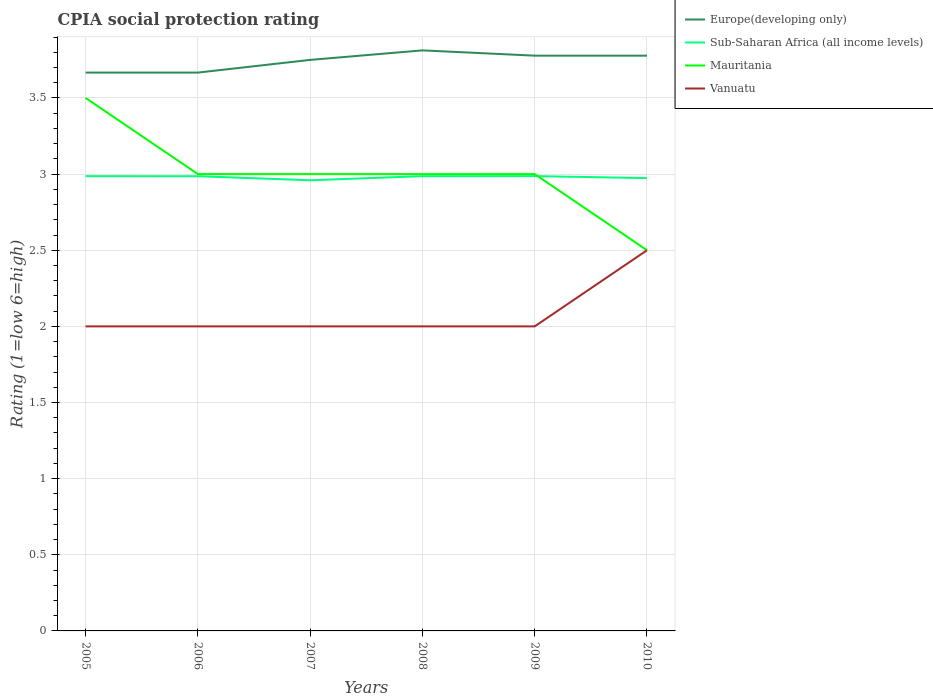Does the line corresponding to Sub-Saharan Africa (all income levels) intersect with the line corresponding to Mauritania?
Your response must be concise. Yes. Across all years, what is the maximum CPIA rating in Sub-Saharan Africa (all income levels)?
Offer a terse response. 2.96. What is the difference between the highest and the second highest CPIA rating in Mauritania?
Your answer should be very brief. 1. What is the difference between the highest and the lowest CPIA rating in Vanuatu?
Your response must be concise. 1. Is the CPIA rating in Vanuatu strictly greater than the CPIA rating in Sub-Saharan Africa (all income levels) over the years?
Offer a very short reply. Yes. What is the difference between two consecutive major ticks on the Y-axis?
Provide a short and direct response. 0.5. Does the graph contain any zero values?
Keep it short and to the point. No. Does the graph contain grids?
Provide a short and direct response. Yes. What is the title of the graph?
Provide a succinct answer. CPIA social protection rating. Does "Jamaica" appear as one of the legend labels in the graph?
Provide a succinct answer. No. What is the label or title of the X-axis?
Offer a terse response. Years. What is the label or title of the Y-axis?
Offer a very short reply. Rating (1=low 6=high). What is the Rating (1=low 6=high) of Europe(developing only) in 2005?
Your response must be concise. 3.67. What is the Rating (1=low 6=high) in Sub-Saharan Africa (all income levels) in 2005?
Your response must be concise. 2.99. What is the Rating (1=low 6=high) in Europe(developing only) in 2006?
Offer a very short reply. 3.67. What is the Rating (1=low 6=high) of Sub-Saharan Africa (all income levels) in 2006?
Provide a succinct answer. 2.99. What is the Rating (1=low 6=high) in Mauritania in 2006?
Your answer should be very brief. 3. What is the Rating (1=low 6=high) of Europe(developing only) in 2007?
Offer a terse response. 3.75. What is the Rating (1=low 6=high) in Sub-Saharan Africa (all income levels) in 2007?
Offer a terse response. 2.96. What is the Rating (1=low 6=high) of Vanuatu in 2007?
Provide a succinct answer. 2. What is the Rating (1=low 6=high) of Europe(developing only) in 2008?
Your answer should be compact. 3.81. What is the Rating (1=low 6=high) of Sub-Saharan Africa (all income levels) in 2008?
Offer a terse response. 2.99. What is the Rating (1=low 6=high) in Vanuatu in 2008?
Your response must be concise. 2. What is the Rating (1=low 6=high) in Europe(developing only) in 2009?
Provide a short and direct response. 3.78. What is the Rating (1=low 6=high) of Sub-Saharan Africa (all income levels) in 2009?
Your answer should be very brief. 2.99. What is the Rating (1=low 6=high) of Mauritania in 2009?
Make the answer very short. 3. What is the Rating (1=low 6=high) in Vanuatu in 2009?
Your response must be concise. 2. What is the Rating (1=low 6=high) in Europe(developing only) in 2010?
Offer a terse response. 3.78. What is the Rating (1=low 6=high) in Sub-Saharan Africa (all income levels) in 2010?
Offer a very short reply. 2.97. What is the Rating (1=low 6=high) of Mauritania in 2010?
Ensure brevity in your answer.  2.5. Across all years, what is the maximum Rating (1=low 6=high) of Europe(developing only)?
Give a very brief answer. 3.81. Across all years, what is the maximum Rating (1=low 6=high) of Sub-Saharan Africa (all income levels)?
Your response must be concise. 2.99. Across all years, what is the maximum Rating (1=low 6=high) in Vanuatu?
Your answer should be compact. 2.5. Across all years, what is the minimum Rating (1=low 6=high) of Europe(developing only)?
Your answer should be compact. 3.67. Across all years, what is the minimum Rating (1=low 6=high) in Sub-Saharan Africa (all income levels)?
Offer a terse response. 2.96. Across all years, what is the minimum Rating (1=low 6=high) in Mauritania?
Offer a terse response. 2.5. Across all years, what is the minimum Rating (1=low 6=high) in Vanuatu?
Your answer should be very brief. 2. What is the total Rating (1=low 6=high) in Europe(developing only) in the graph?
Your answer should be compact. 22.45. What is the total Rating (1=low 6=high) in Sub-Saharan Africa (all income levels) in the graph?
Provide a short and direct response. 17.88. What is the difference between the Rating (1=low 6=high) in Vanuatu in 2005 and that in 2006?
Make the answer very short. 0. What is the difference between the Rating (1=low 6=high) of Europe(developing only) in 2005 and that in 2007?
Your answer should be very brief. -0.08. What is the difference between the Rating (1=low 6=high) of Sub-Saharan Africa (all income levels) in 2005 and that in 2007?
Provide a short and direct response. 0.03. What is the difference between the Rating (1=low 6=high) in Vanuatu in 2005 and that in 2007?
Your answer should be very brief. 0. What is the difference between the Rating (1=low 6=high) of Europe(developing only) in 2005 and that in 2008?
Make the answer very short. -0.15. What is the difference between the Rating (1=low 6=high) in Sub-Saharan Africa (all income levels) in 2005 and that in 2008?
Make the answer very short. 0. What is the difference between the Rating (1=low 6=high) of Mauritania in 2005 and that in 2008?
Your answer should be compact. 0.5. What is the difference between the Rating (1=low 6=high) of Europe(developing only) in 2005 and that in 2009?
Your response must be concise. -0.11. What is the difference between the Rating (1=low 6=high) of Sub-Saharan Africa (all income levels) in 2005 and that in 2009?
Keep it short and to the point. -0. What is the difference between the Rating (1=low 6=high) in Mauritania in 2005 and that in 2009?
Give a very brief answer. 0.5. What is the difference between the Rating (1=low 6=high) of Vanuatu in 2005 and that in 2009?
Offer a terse response. 0. What is the difference between the Rating (1=low 6=high) of Europe(developing only) in 2005 and that in 2010?
Give a very brief answer. -0.11. What is the difference between the Rating (1=low 6=high) of Sub-Saharan Africa (all income levels) in 2005 and that in 2010?
Give a very brief answer. 0.01. What is the difference between the Rating (1=low 6=high) of Mauritania in 2005 and that in 2010?
Your answer should be compact. 1. What is the difference between the Rating (1=low 6=high) in Vanuatu in 2005 and that in 2010?
Offer a very short reply. -0.5. What is the difference between the Rating (1=low 6=high) of Europe(developing only) in 2006 and that in 2007?
Provide a short and direct response. -0.08. What is the difference between the Rating (1=low 6=high) in Sub-Saharan Africa (all income levels) in 2006 and that in 2007?
Provide a short and direct response. 0.03. What is the difference between the Rating (1=low 6=high) in Mauritania in 2006 and that in 2007?
Offer a terse response. 0. What is the difference between the Rating (1=low 6=high) in Vanuatu in 2006 and that in 2007?
Your answer should be very brief. 0. What is the difference between the Rating (1=low 6=high) in Europe(developing only) in 2006 and that in 2008?
Make the answer very short. -0.15. What is the difference between the Rating (1=low 6=high) in Sub-Saharan Africa (all income levels) in 2006 and that in 2008?
Offer a terse response. -0. What is the difference between the Rating (1=low 6=high) of Mauritania in 2006 and that in 2008?
Ensure brevity in your answer.  0. What is the difference between the Rating (1=low 6=high) of Europe(developing only) in 2006 and that in 2009?
Your answer should be very brief. -0.11. What is the difference between the Rating (1=low 6=high) in Sub-Saharan Africa (all income levels) in 2006 and that in 2009?
Provide a succinct answer. -0. What is the difference between the Rating (1=low 6=high) of Mauritania in 2006 and that in 2009?
Make the answer very short. 0. What is the difference between the Rating (1=low 6=high) of Europe(developing only) in 2006 and that in 2010?
Offer a terse response. -0.11. What is the difference between the Rating (1=low 6=high) of Sub-Saharan Africa (all income levels) in 2006 and that in 2010?
Offer a terse response. 0.01. What is the difference between the Rating (1=low 6=high) in Mauritania in 2006 and that in 2010?
Offer a terse response. 0.5. What is the difference between the Rating (1=low 6=high) of Europe(developing only) in 2007 and that in 2008?
Your answer should be very brief. -0.06. What is the difference between the Rating (1=low 6=high) in Sub-Saharan Africa (all income levels) in 2007 and that in 2008?
Keep it short and to the point. -0.03. What is the difference between the Rating (1=low 6=high) in Mauritania in 2007 and that in 2008?
Offer a very short reply. 0. What is the difference between the Rating (1=low 6=high) in Vanuatu in 2007 and that in 2008?
Offer a terse response. 0. What is the difference between the Rating (1=low 6=high) in Europe(developing only) in 2007 and that in 2009?
Your answer should be very brief. -0.03. What is the difference between the Rating (1=low 6=high) in Sub-Saharan Africa (all income levels) in 2007 and that in 2009?
Make the answer very short. -0.03. What is the difference between the Rating (1=low 6=high) in Mauritania in 2007 and that in 2009?
Keep it short and to the point. 0. What is the difference between the Rating (1=low 6=high) in Europe(developing only) in 2007 and that in 2010?
Offer a terse response. -0.03. What is the difference between the Rating (1=low 6=high) in Sub-Saharan Africa (all income levels) in 2007 and that in 2010?
Offer a terse response. -0.01. What is the difference between the Rating (1=low 6=high) of Mauritania in 2007 and that in 2010?
Offer a very short reply. 0.5. What is the difference between the Rating (1=low 6=high) of Vanuatu in 2007 and that in 2010?
Make the answer very short. -0.5. What is the difference between the Rating (1=low 6=high) in Europe(developing only) in 2008 and that in 2009?
Offer a terse response. 0.03. What is the difference between the Rating (1=low 6=high) of Sub-Saharan Africa (all income levels) in 2008 and that in 2009?
Your response must be concise. -0. What is the difference between the Rating (1=low 6=high) of Mauritania in 2008 and that in 2009?
Ensure brevity in your answer.  0. What is the difference between the Rating (1=low 6=high) in Vanuatu in 2008 and that in 2009?
Provide a succinct answer. 0. What is the difference between the Rating (1=low 6=high) of Europe(developing only) in 2008 and that in 2010?
Ensure brevity in your answer.  0.03. What is the difference between the Rating (1=low 6=high) of Sub-Saharan Africa (all income levels) in 2008 and that in 2010?
Your answer should be compact. 0.01. What is the difference between the Rating (1=low 6=high) in Mauritania in 2008 and that in 2010?
Provide a short and direct response. 0.5. What is the difference between the Rating (1=low 6=high) in Sub-Saharan Africa (all income levels) in 2009 and that in 2010?
Provide a succinct answer. 0.01. What is the difference between the Rating (1=low 6=high) of Mauritania in 2009 and that in 2010?
Your answer should be very brief. 0.5. What is the difference between the Rating (1=low 6=high) in Europe(developing only) in 2005 and the Rating (1=low 6=high) in Sub-Saharan Africa (all income levels) in 2006?
Offer a very short reply. 0.68. What is the difference between the Rating (1=low 6=high) of Europe(developing only) in 2005 and the Rating (1=low 6=high) of Mauritania in 2006?
Offer a terse response. 0.67. What is the difference between the Rating (1=low 6=high) in Sub-Saharan Africa (all income levels) in 2005 and the Rating (1=low 6=high) in Mauritania in 2006?
Give a very brief answer. -0.01. What is the difference between the Rating (1=low 6=high) in Sub-Saharan Africa (all income levels) in 2005 and the Rating (1=low 6=high) in Vanuatu in 2006?
Keep it short and to the point. 0.99. What is the difference between the Rating (1=low 6=high) in Europe(developing only) in 2005 and the Rating (1=low 6=high) in Sub-Saharan Africa (all income levels) in 2007?
Offer a very short reply. 0.71. What is the difference between the Rating (1=low 6=high) of Europe(developing only) in 2005 and the Rating (1=low 6=high) of Mauritania in 2007?
Your answer should be very brief. 0.67. What is the difference between the Rating (1=low 6=high) in Sub-Saharan Africa (all income levels) in 2005 and the Rating (1=low 6=high) in Mauritania in 2007?
Keep it short and to the point. -0.01. What is the difference between the Rating (1=low 6=high) of Sub-Saharan Africa (all income levels) in 2005 and the Rating (1=low 6=high) of Vanuatu in 2007?
Your answer should be very brief. 0.99. What is the difference between the Rating (1=low 6=high) in Europe(developing only) in 2005 and the Rating (1=low 6=high) in Sub-Saharan Africa (all income levels) in 2008?
Provide a short and direct response. 0.68. What is the difference between the Rating (1=low 6=high) of Sub-Saharan Africa (all income levels) in 2005 and the Rating (1=low 6=high) of Mauritania in 2008?
Make the answer very short. -0.01. What is the difference between the Rating (1=low 6=high) of Sub-Saharan Africa (all income levels) in 2005 and the Rating (1=low 6=high) of Vanuatu in 2008?
Provide a short and direct response. 0.99. What is the difference between the Rating (1=low 6=high) of Europe(developing only) in 2005 and the Rating (1=low 6=high) of Sub-Saharan Africa (all income levels) in 2009?
Your answer should be very brief. 0.68. What is the difference between the Rating (1=low 6=high) of Europe(developing only) in 2005 and the Rating (1=low 6=high) of Mauritania in 2009?
Give a very brief answer. 0.67. What is the difference between the Rating (1=low 6=high) of Sub-Saharan Africa (all income levels) in 2005 and the Rating (1=low 6=high) of Mauritania in 2009?
Give a very brief answer. -0.01. What is the difference between the Rating (1=low 6=high) in Sub-Saharan Africa (all income levels) in 2005 and the Rating (1=low 6=high) in Vanuatu in 2009?
Provide a short and direct response. 0.99. What is the difference between the Rating (1=low 6=high) in Mauritania in 2005 and the Rating (1=low 6=high) in Vanuatu in 2009?
Provide a short and direct response. 1.5. What is the difference between the Rating (1=low 6=high) in Europe(developing only) in 2005 and the Rating (1=low 6=high) in Sub-Saharan Africa (all income levels) in 2010?
Your answer should be very brief. 0.69. What is the difference between the Rating (1=low 6=high) in Europe(developing only) in 2005 and the Rating (1=low 6=high) in Mauritania in 2010?
Provide a short and direct response. 1.17. What is the difference between the Rating (1=low 6=high) in Europe(developing only) in 2005 and the Rating (1=low 6=high) in Vanuatu in 2010?
Provide a succinct answer. 1.17. What is the difference between the Rating (1=low 6=high) in Sub-Saharan Africa (all income levels) in 2005 and the Rating (1=low 6=high) in Mauritania in 2010?
Your response must be concise. 0.49. What is the difference between the Rating (1=low 6=high) in Sub-Saharan Africa (all income levels) in 2005 and the Rating (1=low 6=high) in Vanuatu in 2010?
Ensure brevity in your answer.  0.49. What is the difference between the Rating (1=low 6=high) of Europe(developing only) in 2006 and the Rating (1=low 6=high) of Sub-Saharan Africa (all income levels) in 2007?
Give a very brief answer. 0.71. What is the difference between the Rating (1=low 6=high) in Europe(developing only) in 2006 and the Rating (1=low 6=high) in Mauritania in 2007?
Give a very brief answer. 0.67. What is the difference between the Rating (1=low 6=high) in Europe(developing only) in 2006 and the Rating (1=low 6=high) in Vanuatu in 2007?
Offer a terse response. 1.67. What is the difference between the Rating (1=low 6=high) of Sub-Saharan Africa (all income levels) in 2006 and the Rating (1=low 6=high) of Mauritania in 2007?
Offer a very short reply. -0.01. What is the difference between the Rating (1=low 6=high) of Sub-Saharan Africa (all income levels) in 2006 and the Rating (1=low 6=high) of Vanuatu in 2007?
Your answer should be very brief. 0.99. What is the difference between the Rating (1=low 6=high) in Europe(developing only) in 2006 and the Rating (1=low 6=high) in Sub-Saharan Africa (all income levels) in 2008?
Your response must be concise. 0.68. What is the difference between the Rating (1=low 6=high) of Sub-Saharan Africa (all income levels) in 2006 and the Rating (1=low 6=high) of Mauritania in 2008?
Offer a very short reply. -0.01. What is the difference between the Rating (1=low 6=high) of Sub-Saharan Africa (all income levels) in 2006 and the Rating (1=low 6=high) of Vanuatu in 2008?
Keep it short and to the point. 0.99. What is the difference between the Rating (1=low 6=high) of Mauritania in 2006 and the Rating (1=low 6=high) of Vanuatu in 2008?
Offer a very short reply. 1. What is the difference between the Rating (1=low 6=high) in Europe(developing only) in 2006 and the Rating (1=low 6=high) in Sub-Saharan Africa (all income levels) in 2009?
Give a very brief answer. 0.68. What is the difference between the Rating (1=low 6=high) in Europe(developing only) in 2006 and the Rating (1=low 6=high) in Vanuatu in 2009?
Your response must be concise. 1.67. What is the difference between the Rating (1=low 6=high) in Sub-Saharan Africa (all income levels) in 2006 and the Rating (1=low 6=high) in Mauritania in 2009?
Give a very brief answer. -0.01. What is the difference between the Rating (1=low 6=high) in Sub-Saharan Africa (all income levels) in 2006 and the Rating (1=low 6=high) in Vanuatu in 2009?
Provide a succinct answer. 0.99. What is the difference between the Rating (1=low 6=high) of Mauritania in 2006 and the Rating (1=low 6=high) of Vanuatu in 2009?
Make the answer very short. 1. What is the difference between the Rating (1=low 6=high) of Europe(developing only) in 2006 and the Rating (1=low 6=high) of Sub-Saharan Africa (all income levels) in 2010?
Keep it short and to the point. 0.69. What is the difference between the Rating (1=low 6=high) in Europe(developing only) in 2006 and the Rating (1=low 6=high) in Mauritania in 2010?
Give a very brief answer. 1.17. What is the difference between the Rating (1=low 6=high) of Europe(developing only) in 2006 and the Rating (1=low 6=high) of Vanuatu in 2010?
Provide a succinct answer. 1.17. What is the difference between the Rating (1=low 6=high) in Sub-Saharan Africa (all income levels) in 2006 and the Rating (1=low 6=high) in Mauritania in 2010?
Give a very brief answer. 0.49. What is the difference between the Rating (1=low 6=high) of Sub-Saharan Africa (all income levels) in 2006 and the Rating (1=low 6=high) of Vanuatu in 2010?
Your answer should be very brief. 0.49. What is the difference between the Rating (1=low 6=high) of Europe(developing only) in 2007 and the Rating (1=low 6=high) of Sub-Saharan Africa (all income levels) in 2008?
Keep it short and to the point. 0.76. What is the difference between the Rating (1=low 6=high) in Europe(developing only) in 2007 and the Rating (1=low 6=high) in Mauritania in 2008?
Offer a very short reply. 0.75. What is the difference between the Rating (1=low 6=high) in Sub-Saharan Africa (all income levels) in 2007 and the Rating (1=low 6=high) in Mauritania in 2008?
Make the answer very short. -0.04. What is the difference between the Rating (1=low 6=high) of Sub-Saharan Africa (all income levels) in 2007 and the Rating (1=low 6=high) of Vanuatu in 2008?
Keep it short and to the point. 0.96. What is the difference between the Rating (1=low 6=high) in Mauritania in 2007 and the Rating (1=low 6=high) in Vanuatu in 2008?
Your response must be concise. 1. What is the difference between the Rating (1=low 6=high) of Europe(developing only) in 2007 and the Rating (1=low 6=high) of Sub-Saharan Africa (all income levels) in 2009?
Make the answer very short. 0.76. What is the difference between the Rating (1=low 6=high) of Sub-Saharan Africa (all income levels) in 2007 and the Rating (1=low 6=high) of Mauritania in 2009?
Your answer should be very brief. -0.04. What is the difference between the Rating (1=low 6=high) of Sub-Saharan Africa (all income levels) in 2007 and the Rating (1=low 6=high) of Vanuatu in 2009?
Keep it short and to the point. 0.96. What is the difference between the Rating (1=low 6=high) in Mauritania in 2007 and the Rating (1=low 6=high) in Vanuatu in 2009?
Provide a succinct answer. 1. What is the difference between the Rating (1=low 6=high) in Europe(developing only) in 2007 and the Rating (1=low 6=high) in Sub-Saharan Africa (all income levels) in 2010?
Your answer should be very brief. 0.78. What is the difference between the Rating (1=low 6=high) in Europe(developing only) in 2007 and the Rating (1=low 6=high) in Mauritania in 2010?
Offer a terse response. 1.25. What is the difference between the Rating (1=low 6=high) in Sub-Saharan Africa (all income levels) in 2007 and the Rating (1=low 6=high) in Mauritania in 2010?
Offer a very short reply. 0.46. What is the difference between the Rating (1=low 6=high) of Sub-Saharan Africa (all income levels) in 2007 and the Rating (1=low 6=high) of Vanuatu in 2010?
Keep it short and to the point. 0.46. What is the difference between the Rating (1=low 6=high) in Mauritania in 2007 and the Rating (1=low 6=high) in Vanuatu in 2010?
Give a very brief answer. 0.5. What is the difference between the Rating (1=low 6=high) in Europe(developing only) in 2008 and the Rating (1=low 6=high) in Sub-Saharan Africa (all income levels) in 2009?
Your answer should be compact. 0.83. What is the difference between the Rating (1=low 6=high) of Europe(developing only) in 2008 and the Rating (1=low 6=high) of Mauritania in 2009?
Provide a short and direct response. 0.81. What is the difference between the Rating (1=low 6=high) in Europe(developing only) in 2008 and the Rating (1=low 6=high) in Vanuatu in 2009?
Ensure brevity in your answer.  1.81. What is the difference between the Rating (1=low 6=high) of Sub-Saharan Africa (all income levels) in 2008 and the Rating (1=low 6=high) of Mauritania in 2009?
Your response must be concise. -0.01. What is the difference between the Rating (1=low 6=high) in Sub-Saharan Africa (all income levels) in 2008 and the Rating (1=low 6=high) in Vanuatu in 2009?
Provide a short and direct response. 0.99. What is the difference between the Rating (1=low 6=high) of Mauritania in 2008 and the Rating (1=low 6=high) of Vanuatu in 2009?
Your answer should be very brief. 1. What is the difference between the Rating (1=low 6=high) in Europe(developing only) in 2008 and the Rating (1=low 6=high) in Sub-Saharan Africa (all income levels) in 2010?
Provide a short and direct response. 0.84. What is the difference between the Rating (1=low 6=high) of Europe(developing only) in 2008 and the Rating (1=low 6=high) of Mauritania in 2010?
Offer a terse response. 1.31. What is the difference between the Rating (1=low 6=high) of Europe(developing only) in 2008 and the Rating (1=low 6=high) of Vanuatu in 2010?
Provide a succinct answer. 1.31. What is the difference between the Rating (1=low 6=high) in Sub-Saharan Africa (all income levels) in 2008 and the Rating (1=low 6=high) in Mauritania in 2010?
Make the answer very short. 0.49. What is the difference between the Rating (1=low 6=high) in Sub-Saharan Africa (all income levels) in 2008 and the Rating (1=low 6=high) in Vanuatu in 2010?
Give a very brief answer. 0.49. What is the difference between the Rating (1=low 6=high) in Mauritania in 2008 and the Rating (1=low 6=high) in Vanuatu in 2010?
Provide a short and direct response. 0.5. What is the difference between the Rating (1=low 6=high) in Europe(developing only) in 2009 and the Rating (1=low 6=high) in Sub-Saharan Africa (all income levels) in 2010?
Your response must be concise. 0.8. What is the difference between the Rating (1=low 6=high) of Europe(developing only) in 2009 and the Rating (1=low 6=high) of Mauritania in 2010?
Give a very brief answer. 1.28. What is the difference between the Rating (1=low 6=high) of Europe(developing only) in 2009 and the Rating (1=low 6=high) of Vanuatu in 2010?
Make the answer very short. 1.28. What is the difference between the Rating (1=low 6=high) in Sub-Saharan Africa (all income levels) in 2009 and the Rating (1=low 6=high) in Mauritania in 2010?
Provide a short and direct response. 0.49. What is the difference between the Rating (1=low 6=high) in Sub-Saharan Africa (all income levels) in 2009 and the Rating (1=low 6=high) in Vanuatu in 2010?
Keep it short and to the point. 0.49. What is the difference between the Rating (1=low 6=high) in Mauritania in 2009 and the Rating (1=low 6=high) in Vanuatu in 2010?
Provide a short and direct response. 0.5. What is the average Rating (1=low 6=high) in Europe(developing only) per year?
Provide a short and direct response. 3.74. What is the average Rating (1=low 6=high) of Sub-Saharan Africa (all income levels) per year?
Give a very brief answer. 2.98. What is the average Rating (1=low 6=high) of Vanuatu per year?
Offer a terse response. 2.08. In the year 2005, what is the difference between the Rating (1=low 6=high) in Europe(developing only) and Rating (1=low 6=high) in Sub-Saharan Africa (all income levels)?
Make the answer very short. 0.68. In the year 2005, what is the difference between the Rating (1=low 6=high) in Europe(developing only) and Rating (1=low 6=high) in Mauritania?
Keep it short and to the point. 0.17. In the year 2005, what is the difference between the Rating (1=low 6=high) in Europe(developing only) and Rating (1=low 6=high) in Vanuatu?
Offer a very short reply. 1.67. In the year 2005, what is the difference between the Rating (1=low 6=high) in Sub-Saharan Africa (all income levels) and Rating (1=low 6=high) in Mauritania?
Offer a terse response. -0.51. In the year 2005, what is the difference between the Rating (1=low 6=high) in Sub-Saharan Africa (all income levels) and Rating (1=low 6=high) in Vanuatu?
Your response must be concise. 0.99. In the year 2006, what is the difference between the Rating (1=low 6=high) in Europe(developing only) and Rating (1=low 6=high) in Sub-Saharan Africa (all income levels)?
Give a very brief answer. 0.68. In the year 2006, what is the difference between the Rating (1=low 6=high) of Europe(developing only) and Rating (1=low 6=high) of Mauritania?
Ensure brevity in your answer.  0.67. In the year 2006, what is the difference between the Rating (1=low 6=high) in Europe(developing only) and Rating (1=low 6=high) in Vanuatu?
Your response must be concise. 1.67. In the year 2006, what is the difference between the Rating (1=low 6=high) in Sub-Saharan Africa (all income levels) and Rating (1=low 6=high) in Mauritania?
Provide a short and direct response. -0.01. In the year 2006, what is the difference between the Rating (1=low 6=high) of Sub-Saharan Africa (all income levels) and Rating (1=low 6=high) of Vanuatu?
Provide a succinct answer. 0.99. In the year 2007, what is the difference between the Rating (1=low 6=high) in Europe(developing only) and Rating (1=low 6=high) in Sub-Saharan Africa (all income levels)?
Ensure brevity in your answer.  0.79. In the year 2007, what is the difference between the Rating (1=low 6=high) of Europe(developing only) and Rating (1=low 6=high) of Vanuatu?
Offer a terse response. 1.75. In the year 2007, what is the difference between the Rating (1=low 6=high) in Sub-Saharan Africa (all income levels) and Rating (1=low 6=high) in Mauritania?
Provide a succinct answer. -0.04. In the year 2007, what is the difference between the Rating (1=low 6=high) of Sub-Saharan Africa (all income levels) and Rating (1=low 6=high) of Vanuatu?
Make the answer very short. 0.96. In the year 2007, what is the difference between the Rating (1=low 6=high) of Mauritania and Rating (1=low 6=high) of Vanuatu?
Provide a succinct answer. 1. In the year 2008, what is the difference between the Rating (1=low 6=high) in Europe(developing only) and Rating (1=low 6=high) in Sub-Saharan Africa (all income levels)?
Provide a succinct answer. 0.83. In the year 2008, what is the difference between the Rating (1=low 6=high) in Europe(developing only) and Rating (1=low 6=high) in Mauritania?
Offer a very short reply. 0.81. In the year 2008, what is the difference between the Rating (1=low 6=high) in Europe(developing only) and Rating (1=low 6=high) in Vanuatu?
Offer a very short reply. 1.81. In the year 2008, what is the difference between the Rating (1=low 6=high) in Sub-Saharan Africa (all income levels) and Rating (1=low 6=high) in Mauritania?
Your answer should be compact. -0.01. In the year 2008, what is the difference between the Rating (1=low 6=high) of Sub-Saharan Africa (all income levels) and Rating (1=low 6=high) of Vanuatu?
Make the answer very short. 0.99. In the year 2008, what is the difference between the Rating (1=low 6=high) in Mauritania and Rating (1=low 6=high) in Vanuatu?
Your answer should be compact. 1. In the year 2009, what is the difference between the Rating (1=low 6=high) in Europe(developing only) and Rating (1=low 6=high) in Sub-Saharan Africa (all income levels)?
Your answer should be very brief. 0.79. In the year 2009, what is the difference between the Rating (1=low 6=high) in Europe(developing only) and Rating (1=low 6=high) in Mauritania?
Keep it short and to the point. 0.78. In the year 2009, what is the difference between the Rating (1=low 6=high) of Europe(developing only) and Rating (1=low 6=high) of Vanuatu?
Provide a succinct answer. 1.78. In the year 2009, what is the difference between the Rating (1=low 6=high) in Sub-Saharan Africa (all income levels) and Rating (1=low 6=high) in Mauritania?
Offer a terse response. -0.01. In the year 2009, what is the difference between the Rating (1=low 6=high) in Mauritania and Rating (1=low 6=high) in Vanuatu?
Offer a terse response. 1. In the year 2010, what is the difference between the Rating (1=low 6=high) in Europe(developing only) and Rating (1=low 6=high) in Sub-Saharan Africa (all income levels)?
Your response must be concise. 0.8. In the year 2010, what is the difference between the Rating (1=low 6=high) in Europe(developing only) and Rating (1=low 6=high) in Mauritania?
Provide a succinct answer. 1.28. In the year 2010, what is the difference between the Rating (1=low 6=high) in Europe(developing only) and Rating (1=low 6=high) in Vanuatu?
Give a very brief answer. 1.28. In the year 2010, what is the difference between the Rating (1=low 6=high) in Sub-Saharan Africa (all income levels) and Rating (1=low 6=high) in Mauritania?
Keep it short and to the point. 0.47. In the year 2010, what is the difference between the Rating (1=low 6=high) in Sub-Saharan Africa (all income levels) and Rating (1=low 6=high) in Vanuatu?
Give a very brief answer. 0.47. What is the ratio of the Rating (1=low 6=high) in Sub-Saharan Africa (all income levels) in 2005 to that in 2006?
Provide a succinct answer. 1. What is the ratio of the Rating (1=low 6=high) in Vanuatu in 2005 to that in 2006?
Make the answer very short. 1. What is the ratio of the Rating (1=low 6=high) of Europe(developing only) in 2005 to that in 2007?
Keep it short and to the point. 0.98. What is the ratio of the Rating (1=low 6=high) of Sub-Saharan Africa (all income levels) in 2005 to that in 2007?
Make the answer very short. 1.01. What is the ratio of the Rating (1=low 6=high) of Vanuatu in 2005 to that in 2007?
Make the answer very short. 1. What is the ratio of the Rating (1=low 6=high) in Europe(developing only) in 2005 to that in 2008?
Your response must be concise. 0.96. What is the ratio of the Rating (1=low 6=high) of Europe(developing only) in 2005 to that in 2009?
Give a very brief answer. 0.97. What is the ratio of the Rating (1=low 6=high) of Vanuatu in 2005 to that in 2009?
Ensure brevity in your answer.  1. What is the ratio of the Rating (1=low 6=high) of Europe(developing only) in 2005 to that in 2010?
Your response must be concise. 0.97. What is the ratio of the Rating (1=low 6=high) in Mauritania in 2005 to that in 2010?
Ensure brevity in your answer.  1.4. What is the ratio of the Rating (1=low 6=high) in Europe(developing only) in 2006 to that in 2007?
Make the answer very short. 0.98. What is the ratio of the Rating (1=low 6=high) of Sub-Saharan Africa (all income levels) in 2006 to that in 2007?
Provide a short and direct response. 1.01. What is the ratio of the Rating (1=low 6=high) in Mauritania in 2006 to that in 2007?
Give a very brief answer. 1. What is the ratio of the Rating (1=low 6=high) in Europe(developing only) in 2006 to that in 2008?
Offer a terse response. 0.96. What is the ratio of the Rating (1=low 6=high) of Sub-Saharan Africa (all income levels) in 2006 to that in 2008?
Your answer should be compact. 1. What is the ratio of the Rating (1=low 6=high) in Mauritania in 2006 to that in 2008?
Ensure brevity in your answer.  1. What is the ratio of the Rating (1=low 6=high) of Europe(developing only) in 2006 to that in 2009?
Give a very brief answer. 0.97. What is the ratio of the Rating (1=low 6=high) in Europe(developing only) in 2006 to that in 2010?
Keep it short and to the point. 0.97. What is the ratio of the Rating (1=low 6=high) in Mauritania in 2006 to that in 2010?
Keep it short and to the point. 1.2. What is the ratio of the Rating (1=low 6=high) of Europe(developing only) in 2007 to that in 2008?
Your answer should be compact. 0.98. What is the ratio of the Rating (1=low 6=high) in Vanuatu in 2007 to that in 2008?
Your answer should be compact. 1. What is the ratio of the Rating (1=low 6=high) in Europe(developing only) in 2007 to that in 2009?
Your answer should be very brief. 0.99. What is the ratio of the Rating (1=low 6=high) of Sub-Saharan Africa (all income levels) in 2007 to that in 2009?
Give a very brief answer. 0.99. What is the ratio of the Rating (1=low 6=high) of Vanuatu in 2007 to that in 2009?
Provide a succinct answer. 1. What is the ratio of the Rating (1=low 6=high) in Europe(developing only) in 2007 to that in 2010?
Your response must be concise. 0.99. What is the ratio of the Rating (1=low 6=high) of Sub-Saharan Africa (all income levels) in 2007 to that in 2010?
Give a very brief answer. 1. What is the ratio of the Rating (1=low 6=high) in Europe(developing only) in 2008 to that in 2009?
Provide a short and direct response. 1.01. What is the ratio of the Rating (1=low 6=high) of Sub-Saharan Africa (all income levels) in 2008 to that in 2009?
Make the answer very short. 1. What is the ratio of the Rating (1=low 6=high) of Vanuatu in 2008 to that in 2009?
Provide a short and direct response. 1. What is the ratio of the Rating (1=low 6=high) in Europe(developing only) in 2008 to that in 2010?
Give a very brief answer. 1.01. What is the ratio of the Rating (1=low 6=high) in Mauritania in 2008 to that in 2010?
Your answer should be very brief. 1.2. What is the ratio of the Rating (1=low 6=high) of Europe(developing only) in 2009 to that in 2010?
Keep it short and to the point. 1. What is the ratio of the Rating (1=low 6=high) in Mauritania in 2009 to that in 2010?
Keep it short and to the point. 1.2. What is the ratio of the Rating (1=low 6=high) of Vanuatu in 2009 to that in 2010?
Your answer should be compact. 0.8. What is the difference between the highest and the second highest Rating (1=low 6=high) in Europe(developing only)?
Provide a succinct answer. 0.03. What is the difference between the highest and the second highest Rating (1=low 6=high) of Mauritania?
Keep it short and to the point. 0.5. What is the difference between the highest and the lowest Rating (1=low 6=high) of Europe(developing only)?
Your answer should be very brief. 0.15. What is the difference between the highest and the lowest Rating (1=low 6=high) of Sub-Saharan Africa (all income levels)?
Your response must be concise. 0.03. What is the difference between the highest and the lowest Rating (1=low 6=high) of Mauritania?
Offer a terse response. 1. What is the difference between the highest and the lowest Rating (1=low 6=high) of Vanuatu?
Provide a short and direct response. 0.5. 